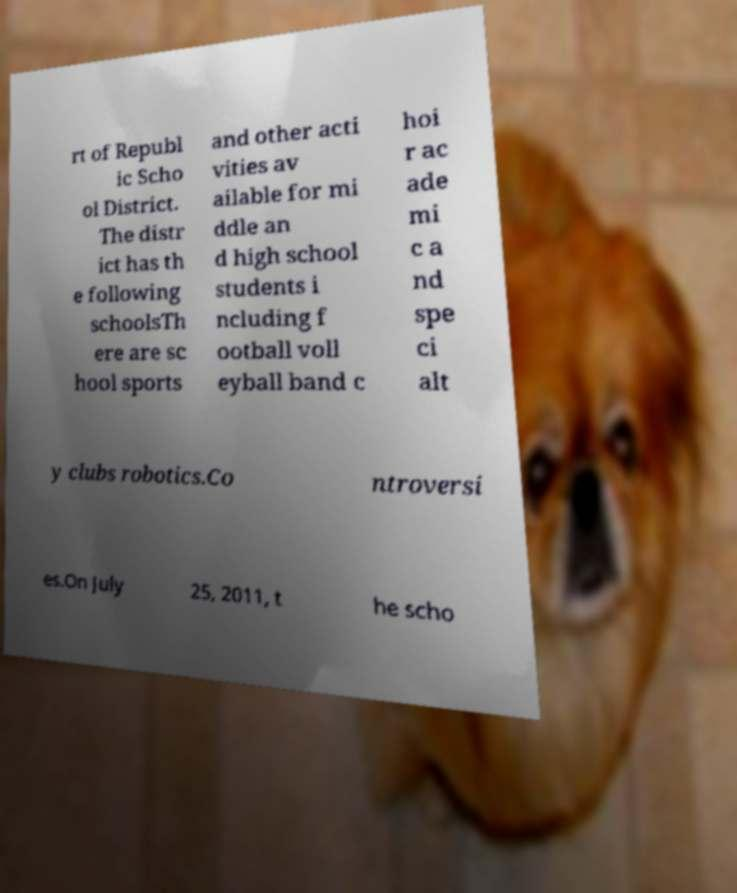Please identify and transcribe the text found in this image. rt of Republ ic Scho ol District. The distr ict has th e following schoolsTh ere are sc hool sports and other acti vities av ailable for mi ddle an d high school students i ncluding f ootball voll eyball band c hoi r ac ade mi c a nd spe ci alt y clubs robotics.Co ntroversi es.On July 25, 2011, t he scho 